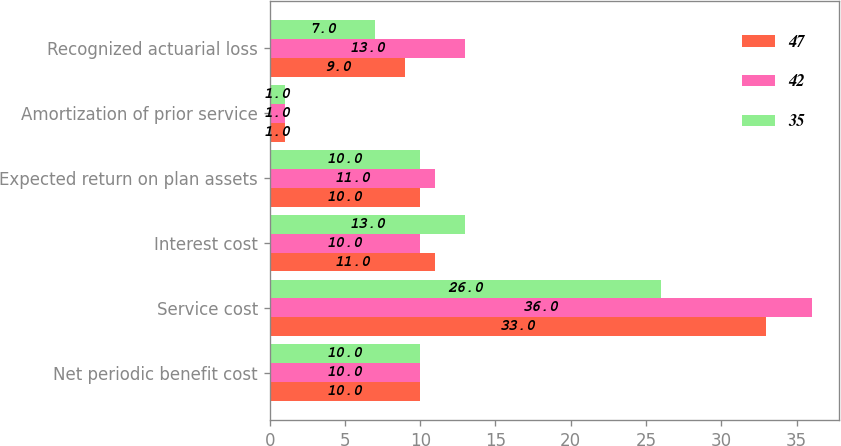Convert chart to OTSL. <chart><loc_0><loc_0><loc_500><loc_500><stacked_bar_chart><ecel><fcel>Net periodic benefit cost<fcel>Service cost<fcel>Interest cost<fcel>Expected return on plan assets<fcel>Amortization of prior service<fcel>Recognized actuarial loss<nl><fcel>47<fcel>10<fcel>33<fcel>11<fcel>10<fcel>1<fcel>9<nl><fcel>42<fcel>10<fcel>36<fcel>10<fcel>11<fcel>1<fcel>13<nl><fcel>35<fcel>10<fcel>26<fcel>13<fcel>10<fcel>1<fcel>7<nl></chart> 